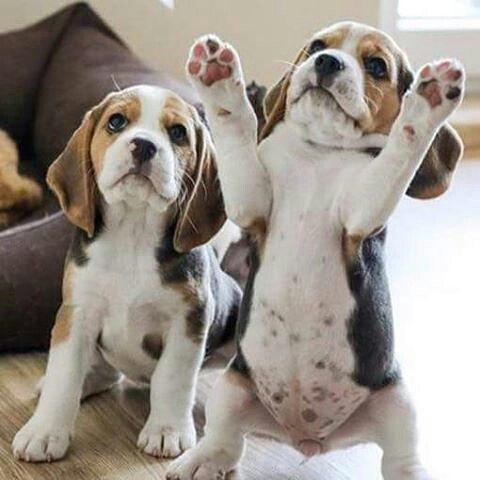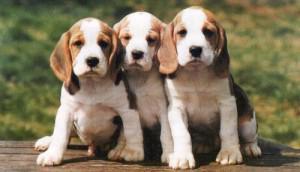The first image is the image on the left, the second image is the image on the right. Examine the images to the left and right. Is the description "One of the images has exactly two dogs." accurate? Answer yes or no. Yes. The first image is the image on the left, the second image is the image on the right. Considering the images on both sides, is "There are at most five dogs." valid? Answer yes or no. Yes. 